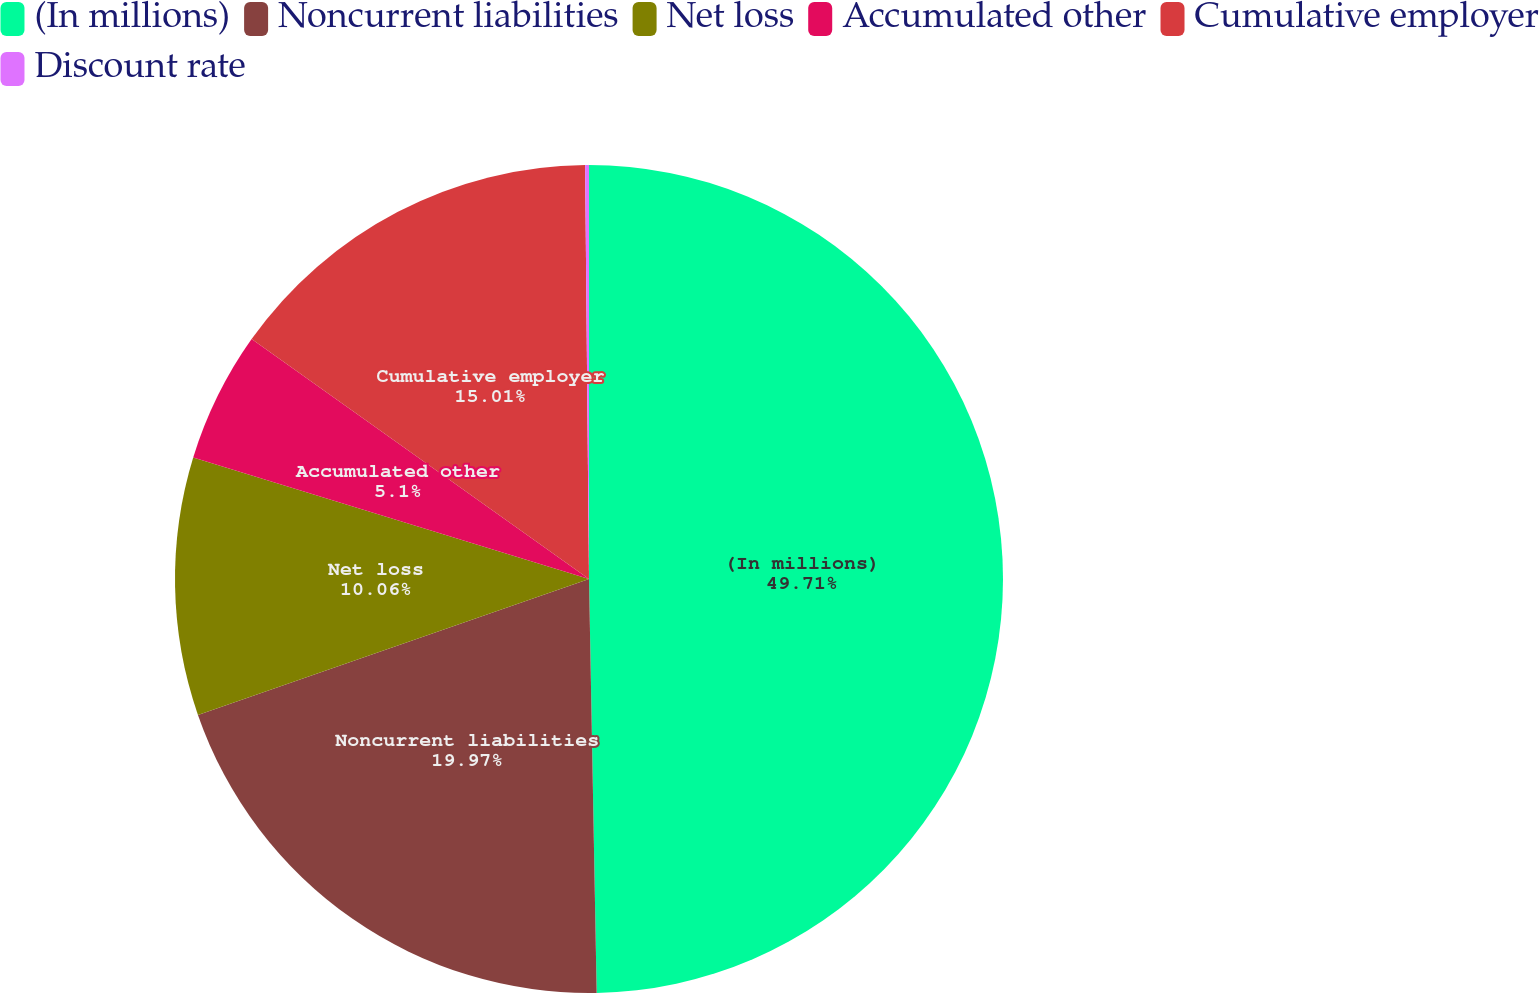Convert chart to OTSL. <chart><loc_0><loc_0><loc_500><loc_500><pie_chart><fcel>(In millions)<fcel>Noncurrent liabilities<fcel>Net loss<fcel>Accumulated other<fcel>Cumulative employer<fcel>Discount rate<nl><fcel>49.7%<fcel>19.97%<fcel>10.06%<fcel>5.1%<fcel>15.01%<fcel>0.15%<nl></chart> 